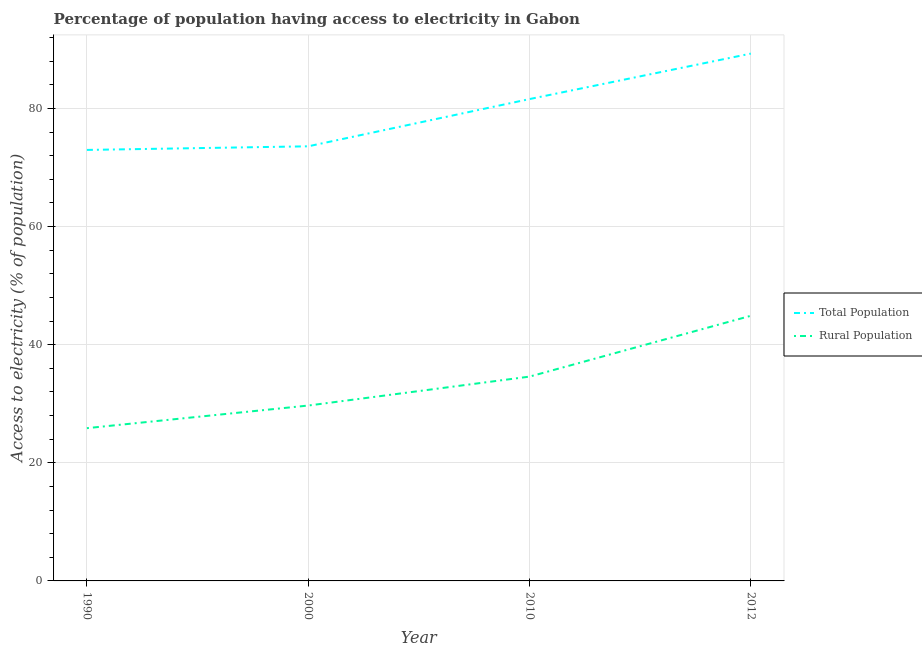How many different coloured lines are there?
Your response must be concise. 2. What is the percentage of rural population having access to electricity in 1990?
Your answer should be compact. 25.87. Across all years, what is the maximum percentage of rural population having access to electricity?
Give a very brief answer. 44.9. Across all years, what is the minimum percentage of population having access to electricity?
Ensure brevity in your answer.  72.99. In which year was the percentage of rural population having access to electricity maximum?
Provide a succinct answer. 2012. In which year was the percentage of population having access to electricity minimum?
Your response must be concise. 1990. What is the total percentage of population having access to electricity in the graph?
Make the answer very short. 317.49. What is the difference between the percentage of rural population having access to electricity in 2000 and that in 2012?
Your answer should be compact. -15.2. What is the difference between the percentage of population having access to electricity in 2010 and the percentage of rural population having access to electricity in 2012?
Your answer should be compact. 36.7. What is the average percentage of rural population having access to electricity per year?
Provide a short and direct response. 33.77. In the year 1990, what is the difference between the percentage of rural population having access to electricity and percentage of population having access to electricity?
Ensure brevity in your answer.  -47.12. What is the ratio of the percentage of rural population having access to electricity in 2000 to that in 2010?
Offer a terse response. 0.86. Is the percentage of population having access to electricity in 2010 less than that in 2012?
Give a very brief answer. Yes. Is the difference between the percentage of rural population having access to electricity in 1990 and 2010 greater than the difference between the percentage of population having access to electricity in 1990 and 2010?
Ensure brevity in your answer.  No. What is the difference between the highest and the second highest percentage of rural population having access to electricity?
Give a very brief answer. 10.3. What is the difference between the highest and the lowest percentage of population having access to electricity?
Offer a very short reply. 16.31. Is the sum of the percentage of population having access to electricity in 2000 and 2010 greater than the maximum percentage of rural population having access to electricity across all years?
Give a very brief answer. Yes. How many years are there in the graph?
Make the answer very short. 4. What is the difference between two consecutive major ticks on the Y-axis?
Your answer should be compact. 20. Are the values on the major ticks of Y-axis written in scientific E-notation?
Make the answer very short. No. Does the graph contain any zero values?
Make the answer very short. No. How many legend labels are there?
Offer a very short reply. 2. What is the title of the graph?
Make the answer very short. Percentage of population having access to electricity in Gabon. What is the label or title of the Y-axis?
Provide a succinct answer. Access to electricity (% of population). What is the Access to electricity (% of population) of Total Population in 1990?
Your answer should be very brief. 72.99. What is the Access to electricity (% of population) of Rural Population in 1990?
Make the answer very short. 25.87. What is the Access to electricity (% of population) in Total Population in 2000?
Ensure brevity in your answer.  73.6. What is the Access to electricity (% of population) of Rural Population in 2000?
Your answer should be very brief. 29.7. What is the Access to electricity (% of population) in Total Population in 2010?
Give a very brief answer. 81.6. What is the Access to electricity (% of population) of Rural Population in 2010?
Your response must be concise. 34.6. What is the Access to electricity (% of population) in Total Population in 2012?
Your response must be concise. 89.3. What is the Access to electricity (% of population) of Rural Population in 2012?
Give a very brief answer. 44.9. Across all years, what is the maximum Access to electricity (% of population) in Total Population?
Offer a terse response. 89.3. Across all years, what is the maximum Access to electricity (% of population) in Rural Population?
Provide a short and direct response. 44.9. Across all years, what is the minimum Access to electricity (% of population) in Total Population?
Offer a very short reply. 72.99. Across all years, what is the minimum Access to electricity (% of population) in Rural Population?
Make the answer very short. 25.87. What is the total Access to electricity (% of population) in Total Population in the graph?
Ensure brevity in your answer.  317.49. What is the total Access to electricity (% of population) in Rural Population in the graph?
Make the answer very short. 135.07. What is the difference between the Access to electricity (% of population) in Total Population in 1990 and that in 2000?
Give a very brief answer. -0.61. What is the difference between the Access to electricity (% of population) in Rural Population in 1990 and that in 2000?
Keep it short and to the point. -3.83. What is the difference between the Access to electricity (% of population) of Total Population in 1990 and that in 2010?
Provide a short and direct response. -8.61. What is the difference between the Access to electricity (% of population) in Rural Population in 1990 and that in 2010?
Keep it short and to the point. -8.73. What is the difference between the Access to electricity (% of population) of Total Population in 1990 and that in 2012?
Offer a very short reply. -16.31. What is the difference between the Access to electricity (% of population) of Rural Population in 1990 and that in 2012?
Ensure brevity in your answer.  -19.03. What is the difference between the Access to electricity (% of population) of Total Population in 2000 and that in 2012?
Your response must be concise. -15.7. What is the difference between the Access to electricity (% of population) of Rural Population in 2000 and that in 2012?
Your answer should be compact. -15.2. What is the difference between the Access to electricity (% of population) in Rural Population in 2010 and that in 2012?
Keep it short and to the point. -10.3. What is the difference between the Access to electricity (% of population) in Total Population in 1990 and the Access to electricity (% of population) in Rural Population in 2000?
Provide a succinct answer. 43.29. What is the difference between the Access to electricity (% of population) of Total Population in 1990 and the Access to electricity (% of population) of Rural Population in 2010?
Ensure brevity in your answer.  38.39. What is the difference between the Access to electricity (% of population) of Total Population in 1990 and the Access to electricity (% of population) of Rural Population in 2012?
Your answer should be very brief. 28.09. What is the difference between the Access to electricity (% of population) of Total Population in 2000 and the Access to electricity (% of population) of Rural Population in 2010?
Your answer should be very brief. 39. What is the difference between the Access to electricity (% of population) in Total Population in 2000 and the Access to electricity (% of population) in Rural Population in 2012?
Ensure brevity in your answer.  28.7. What is the difference between the Access to electricity (% of population) of Total Population in 2010 and the Access to electricity (% of population) of Rural Population in 2012?
Your answer should be very brief. 36.7. What is the average Access to electricity (% of population) of Total Population per year?
Give a very brief answer. 79.37. What is the average Access to electricity (% of population) in Rural Population per year?
Make the answer very short. 33.77. In the year 1990, what is the difference between the Access to electricity (% of population) of Total Population and Access to electricity (% of population) of Rural Population?
Your response must be concise. 47.12. In the year 2000, what is the difference between the Access to electricity (% of population) in Total Population and Access to electricity (% of population) in Rural Population?
Offer a very short reply. 43.9. In the year 2010, what is the difference between the Access to electricity (% of population) of Total Population and Access to electricity (% of population) of Rural Population?
Your answer should be compact. 47. In the year 2012, what is the difference between the Access to electricity (% of population) of Total Population and Access to electricity (% of population) of Rural Population?
Provide a short and direct response. 44.4. What is the ratio of the Access to electricity (% of population) in Total Population in 1990 to that in 2000?
Provide a succinct answer. 0.99. What is the ratio of the Access to electricity (% of population) in Rural Population in 1990 to that in 2000?
Your response must be concise. 0.87. What is the ratio of the Access to electricity (% of population) of Total Population in 1990 to that in 2010?
Ensure brevity in your answer.  0.89. What is the ratio of the Access to electricity (% of population) of Rural Population in 1990 to that in 2010?
Your answer should be very brief. 0.75. What is the ratio of the Access to electricity (% of population) of Total Population in 1990 to that in 2012?
Your answer should be very brief. 0.82. What is the ratio of the Access to electricity (% of population) in Rural Population in 1990 to that in 2012?
Your answer should be very brief. 0.58. What is the ratio of the Access to electricity (% of population) of Total Population in 2000 to that in 2010?
Offer a terse response. 0.9. What is the ratio of the Access to electricity (% of population) in Rural Population in 2000 to that in 2010?
Offer a very short reply. 0.86. What is the ratio of the Access to electricity (% of population) in Total Population in 2000 to that in 2012?
Offer a very short reply. 0.82. What is the ratio of the Access to electricity (% of population) in Rural Population in 2000 to that in 2012?
Keep it short and to the point. 0.66. What is the ratio of the Access to electricity (% of population) in Total Population in 2010 to that in 2012?
Offer a terse response. 0.91. What is the ratio of the Access to electricity (% of population) of Rural Population in 2010 to that in 2012?
Give a very brief answer. 0.77. What is the difference between the highest and the lowest Access to electricity (% of population) of Total Population?
Your answer should be very brief. 16.31. What is the difference between the highest and the lowest Access to electricity (% of population) of Rural Population?
Make the answer very short. 19.03. 